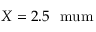Convert formula to latex. <formula><loc_0><loc_0><loc_500><loc_500>X = 2 . 5 \ m u m</formula> 